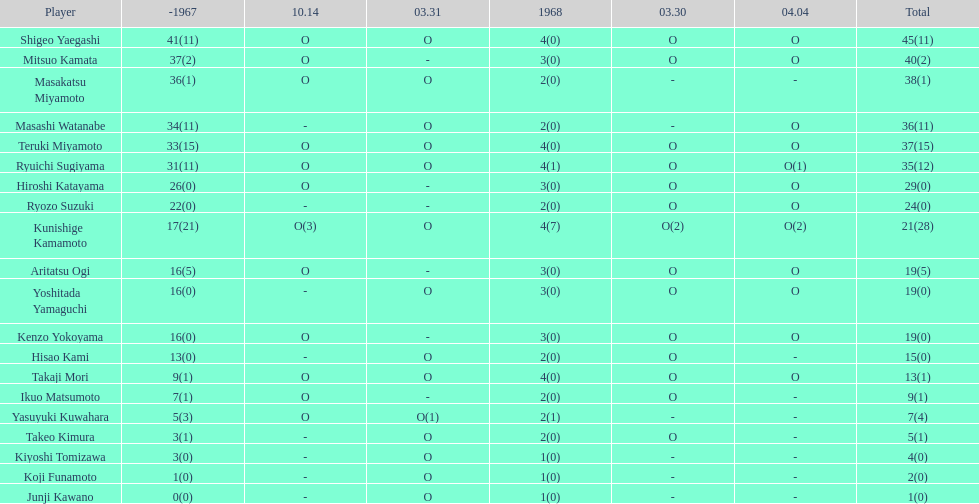How many more total appearances did shigeo yaegashi have than mitsuo kamata? 5. 